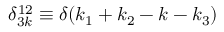Convert formula to latex. <formula><loc_0><loc_0><loc_500><loc_500>\delta _ { 3 k } ^ { 1 2 } \equiv \delta ( k _ { 1 } + k _ { 2 } - k - k _ { 3 } )</formula> 